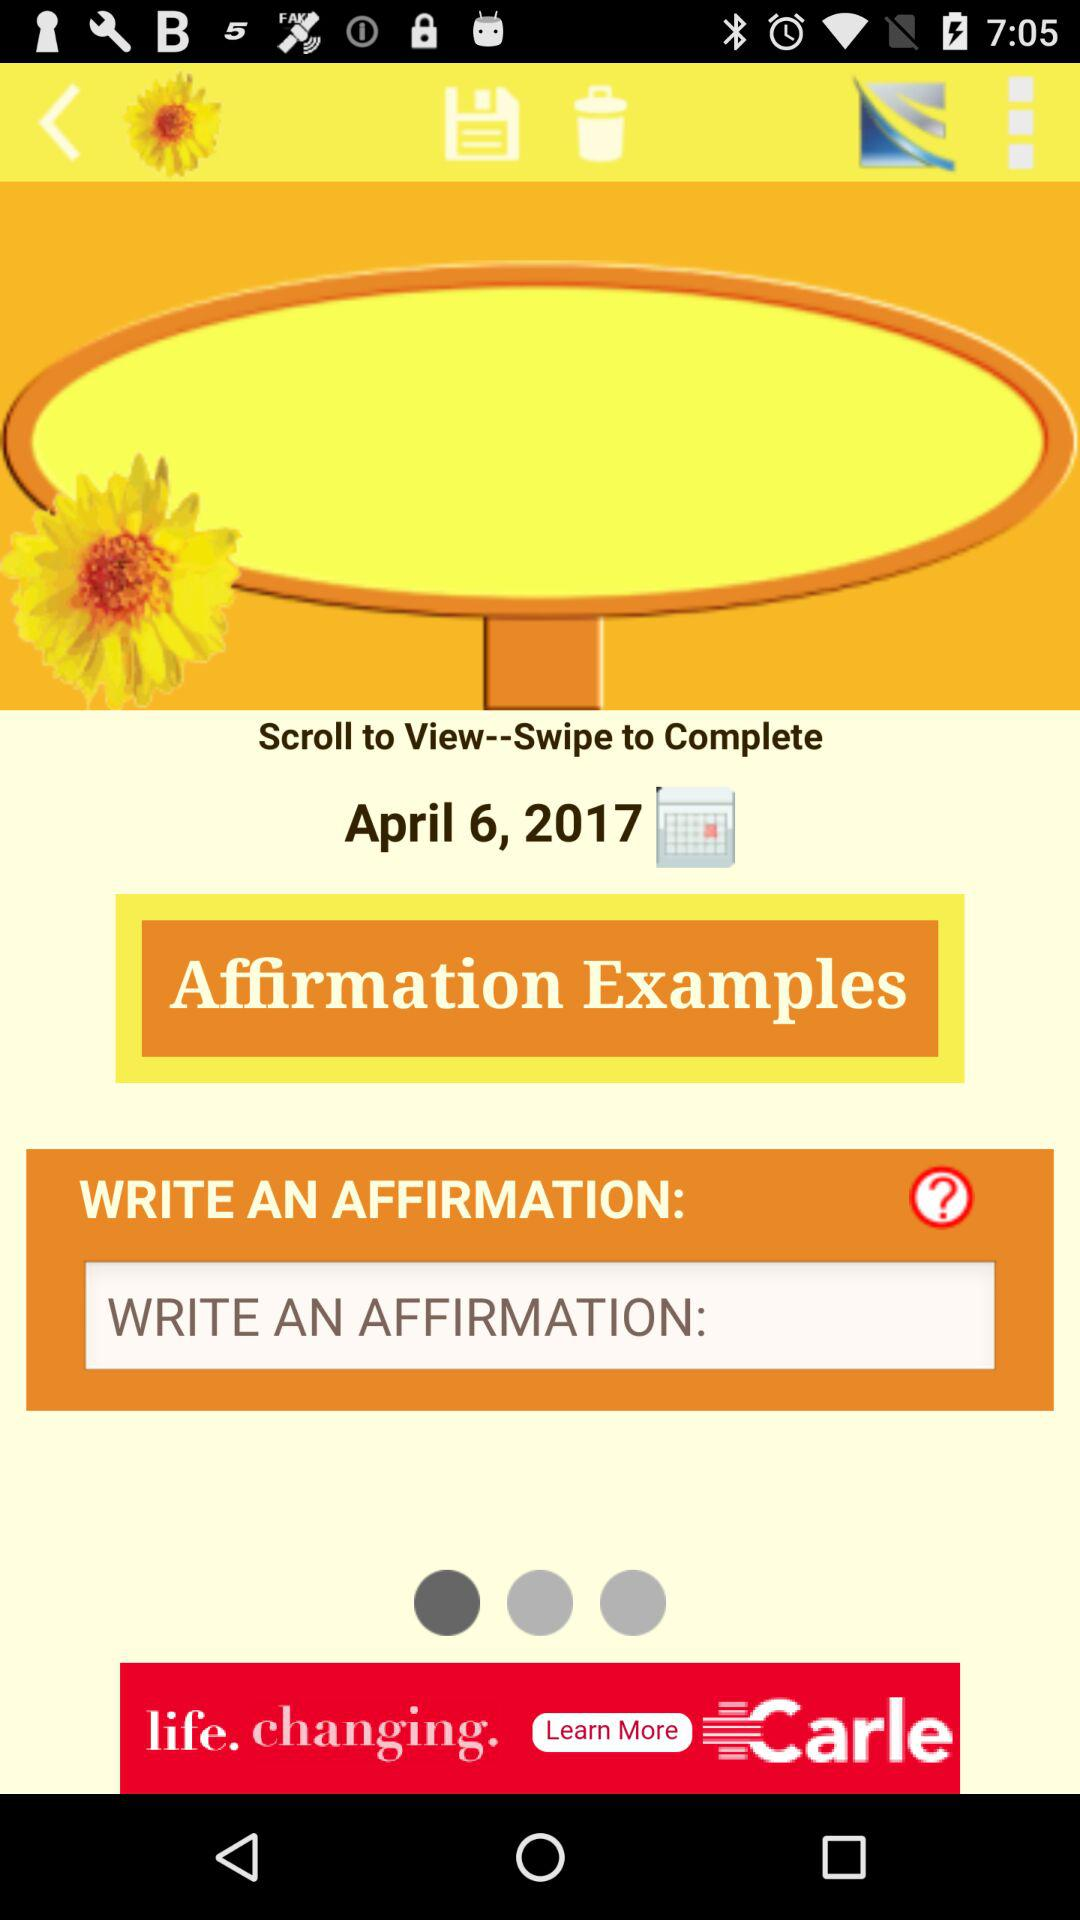What is the date? The date is April 6, 2017. 